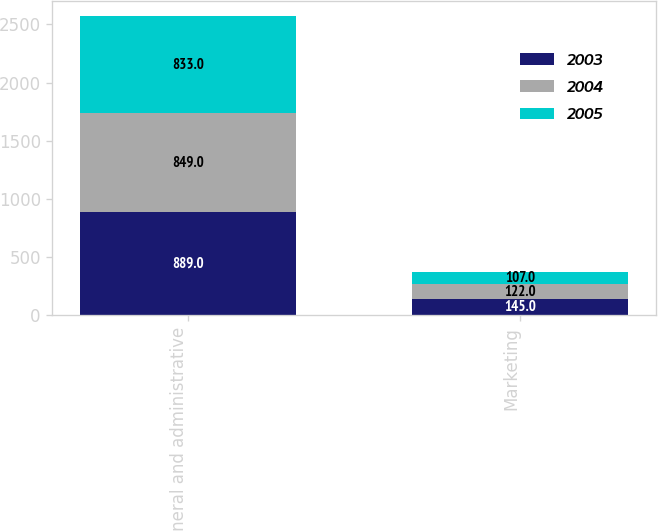Convert chart to OTSL. <chart><loc_0><loc_0><loc_500><loc_500><stacked_bar_chart><ecel><fcel>General and administrative<fcel>Marketing<nl><fcel>2003<fcel>889<fcel>145<nl><fcel>2004<fcel>849<fcel>122<nl><fcel>2005<fcel>833<fcel>107<nl></chart> 